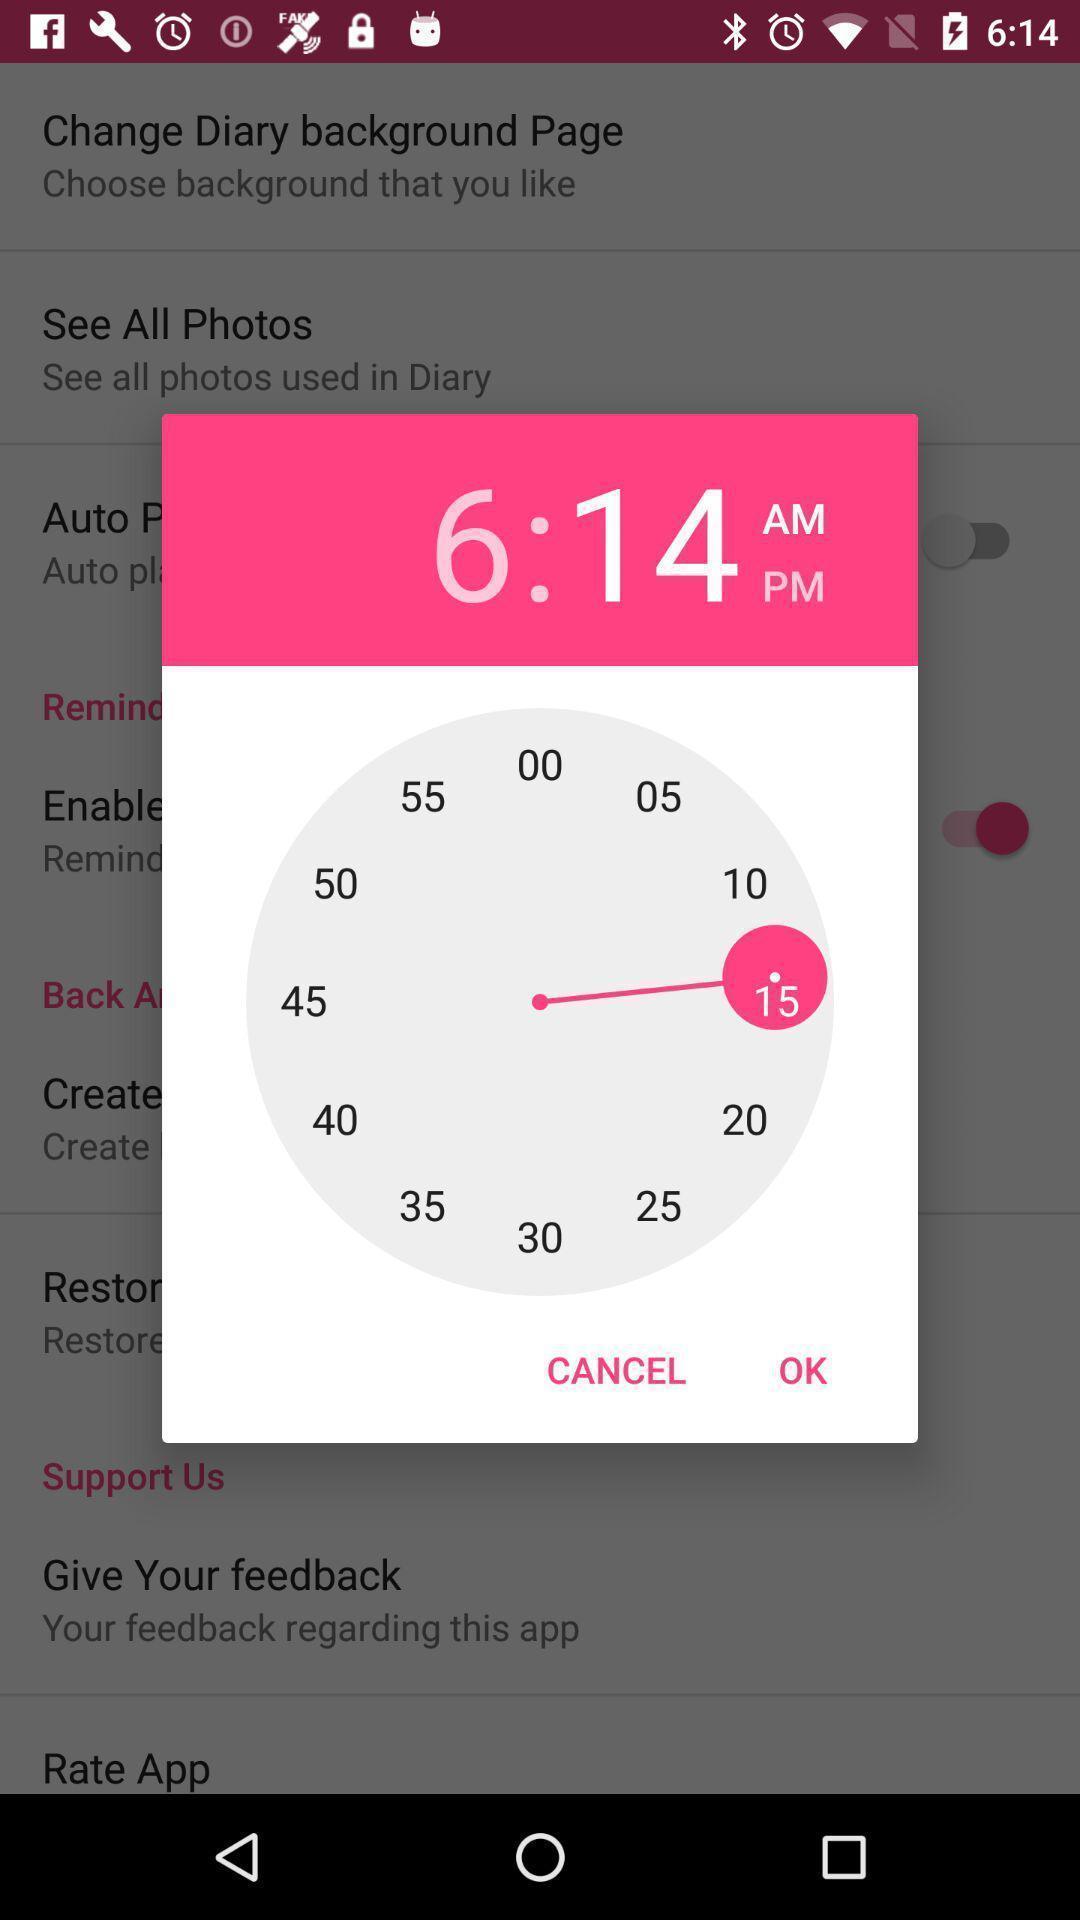Describe the key features of this screenshot. Screen showing a pop up of a clock. 